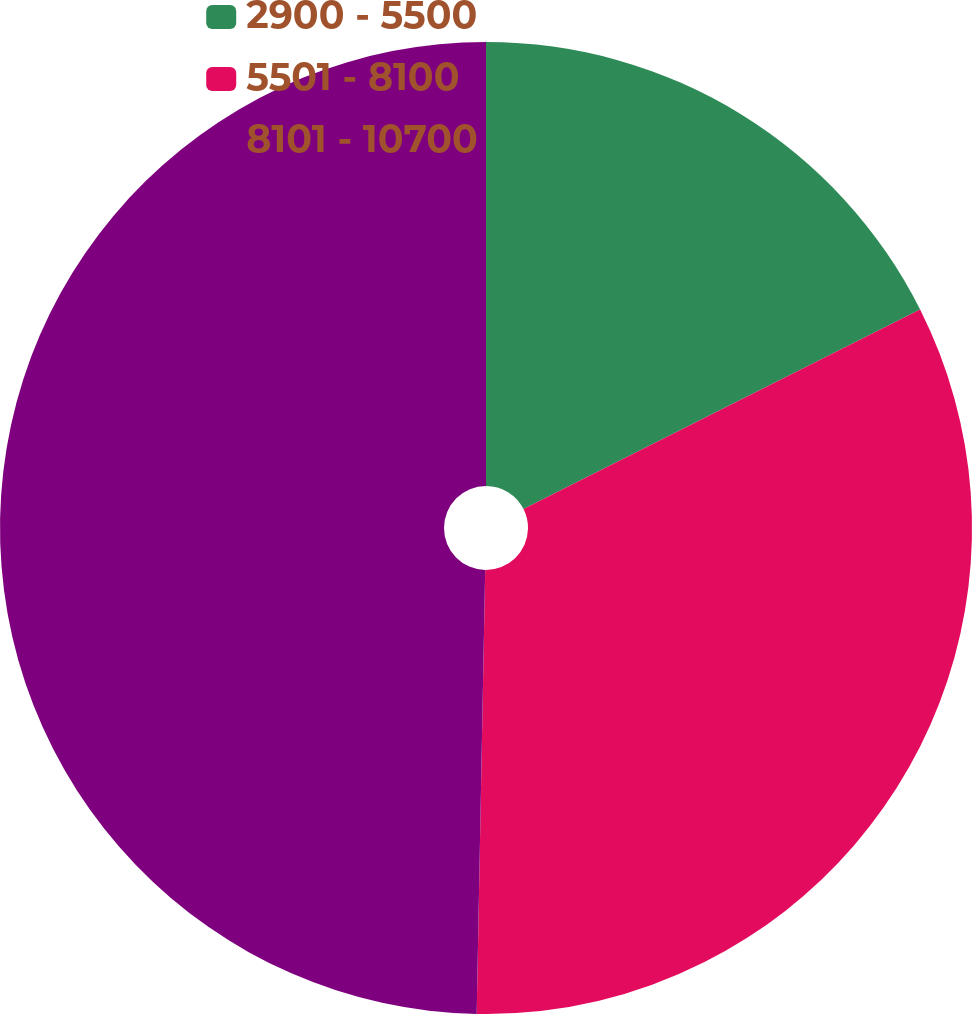Convert chart. <chart><loc_0><loc_0><loc_500><loc_500><pie_chart><fcel>2900 - 5500<fcel>5501 - 8100<fcel>8101 - 10700<nl><fcel>17.58%<fcel>32.73%<fcel>49.7%<nl></chart> 